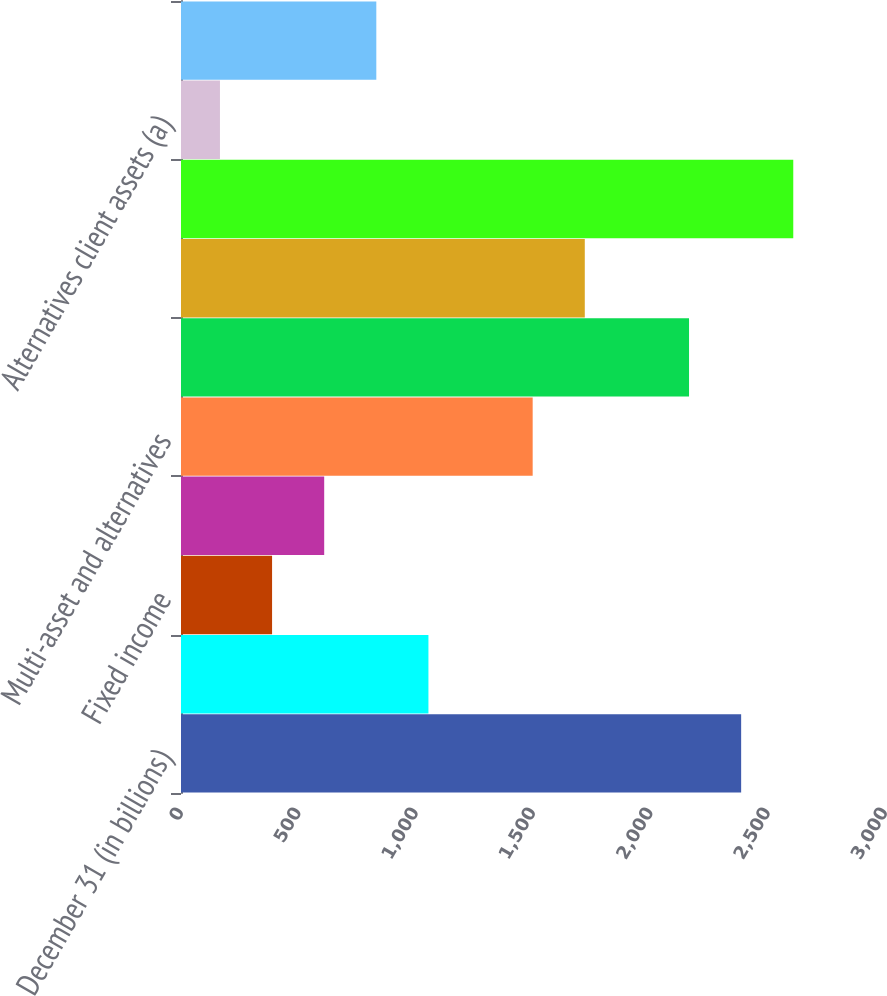<chart> <loc_0><loc_0><loc_500><loc_500><bar_chart><fcel>December 31 (in billions)<fcel>Liquidity<fcel>Fixed income<fcel>Equity<fcel>Multi-asset and alternatives<fcel>Total assets under management<fcel>Unnamed: 6<fcel>Total client assets<fcel>Alternatives client assets (a)<fcel>Private Banking<nl><fcel>2387<fcel>1054.4<fcel>388.1<fcel>610.2<fcel>1498.6<fcel>2164.9<fcel>1720.7<fcel>2609.1<fcel>166<fcel>832.3<nl></chart> 